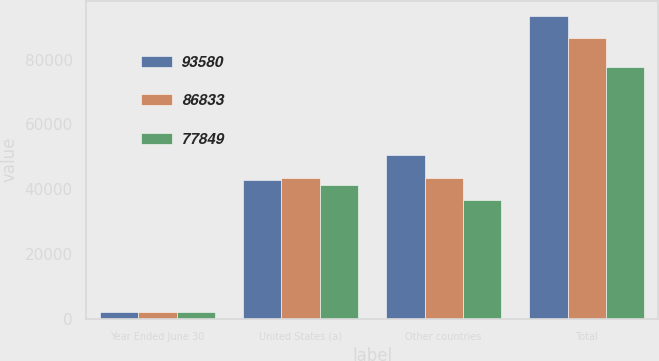<chart> <loc_0><loc_0><loc_500><loc_500><stacked_bar_chart><ecel><fcel>Year Ended June 30<fcel>United States (a)<fcel>Other countries<fcel>Total<nl><fcel>93580<fcel>2015<fcel>42941<fcel>50639<fcel>93580<nl><fcel>86833<fcel>2014<fcel>43474<fcel>43359<fcel>86833<nl><fcel>77849<fcel>2013<fcel>41344<fcel>36505<fcel>77849<nl></chart> 